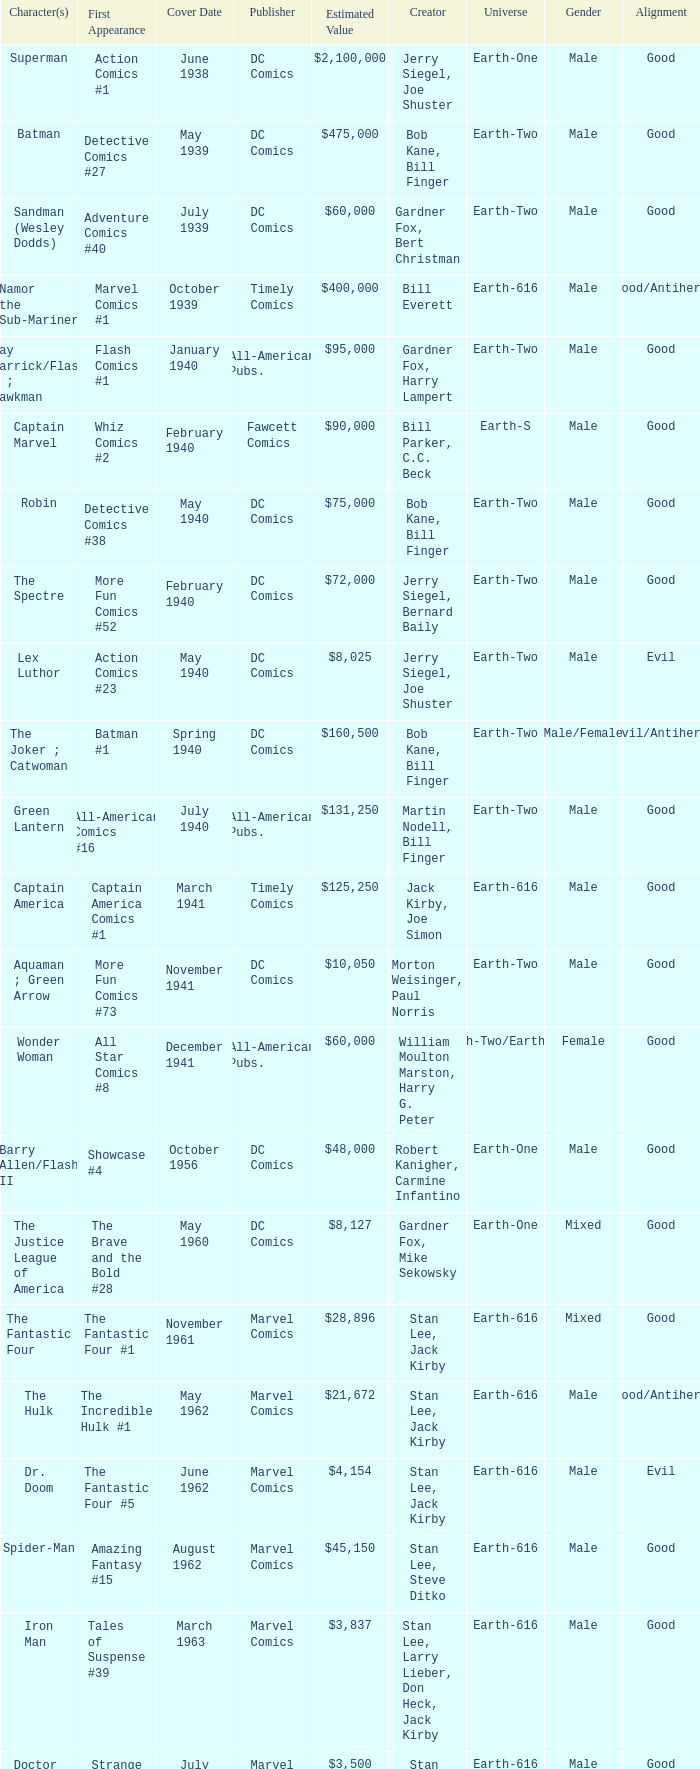What is Action Comics #1's estimated value? $2,100,000. 